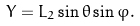<formula> <loc_0><loc_0><loc_500><loc_500>Y = L _ { 2 } \sin \theta \sin \varphi .</formula> 